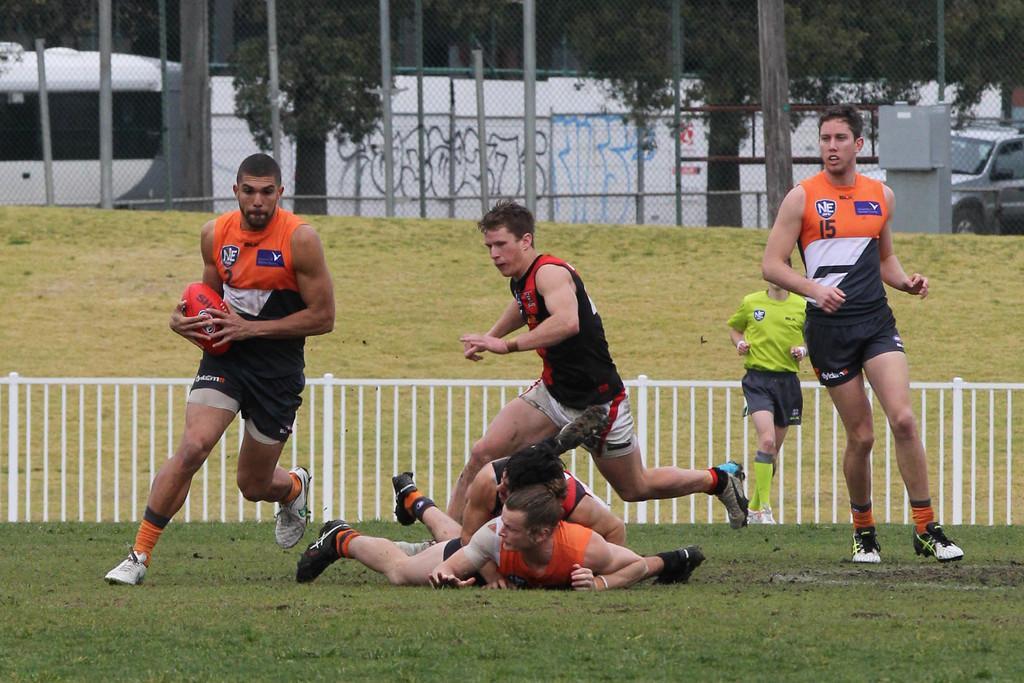Please provide a concise description of this image. In this image, we can see people wearing sports dress and one of them is holding a ball. In the background, there is a railing and we can see trees, poles, vehicles on the road and we can see some text on the wall and there is a fence. 